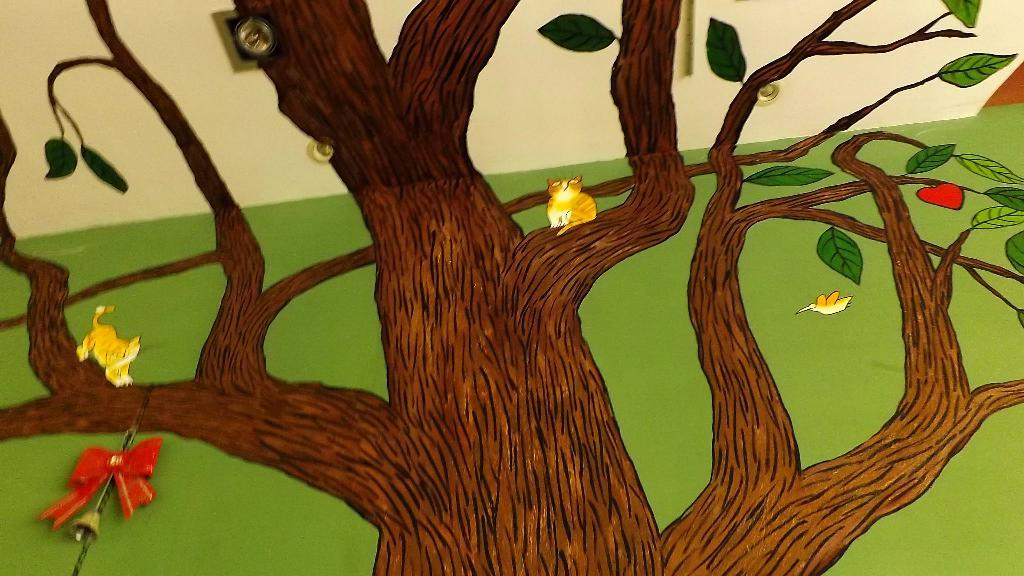What is depicted on the painting that is on the wall in the image? There is a painting of a tree on the wall in the image. What color is the wall that the painting is on? The wall is green in color. What is hanging on the wall in addition to the painting? There is a wall hanging with a bell on the wall. What can be seen on the ceiling in the image? There are lights on the ceiling. Where is the toothbrush located in the image? There is no toothbrush present in the image. What type of bread is being used to decorate the wall hanging with a bell? There is no bread present in the image. 